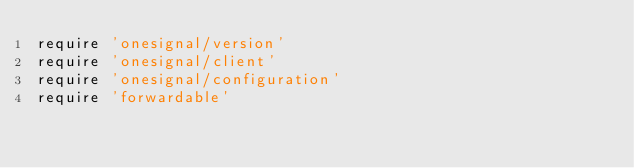Convert code to text. <code><loc_0><loc_0><loc_500><loc_500><_Ruby_>require 'onesignal/version'
require 'onesignal/client'
require 'onesignal/configuration'
require 'forwardable'
</code> 